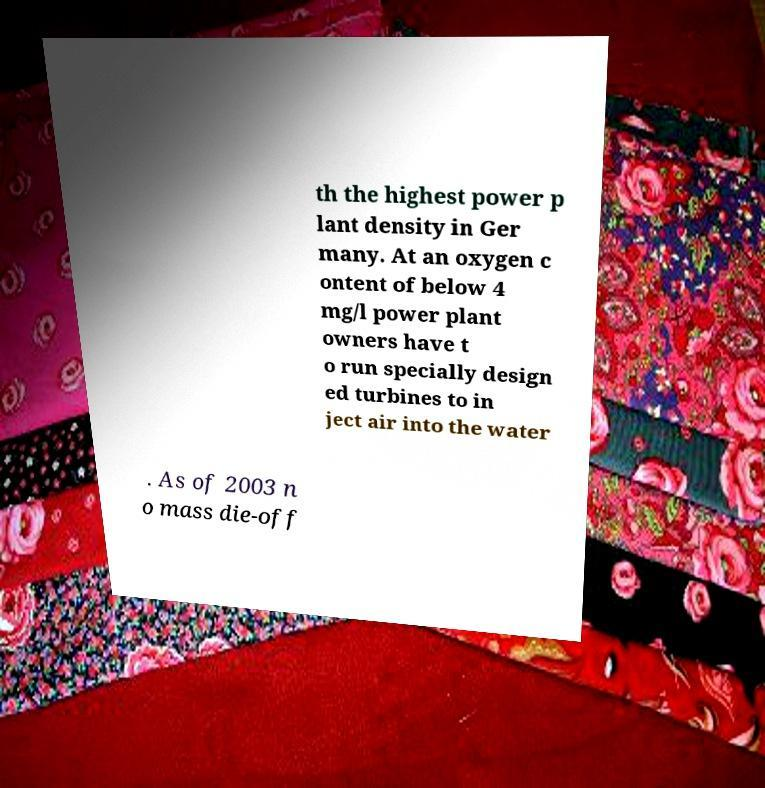Can you read and provide the text displayed in the image?This photo seems to have some interesting text. Can you extract and type it out for me? th the highest power p lant density in Ger many. At an oxygen c ontent of below 4 mg/l power plant owners have t o run specially design ed turbines to in ject air into the water . As of 2003 n o mass die-off 